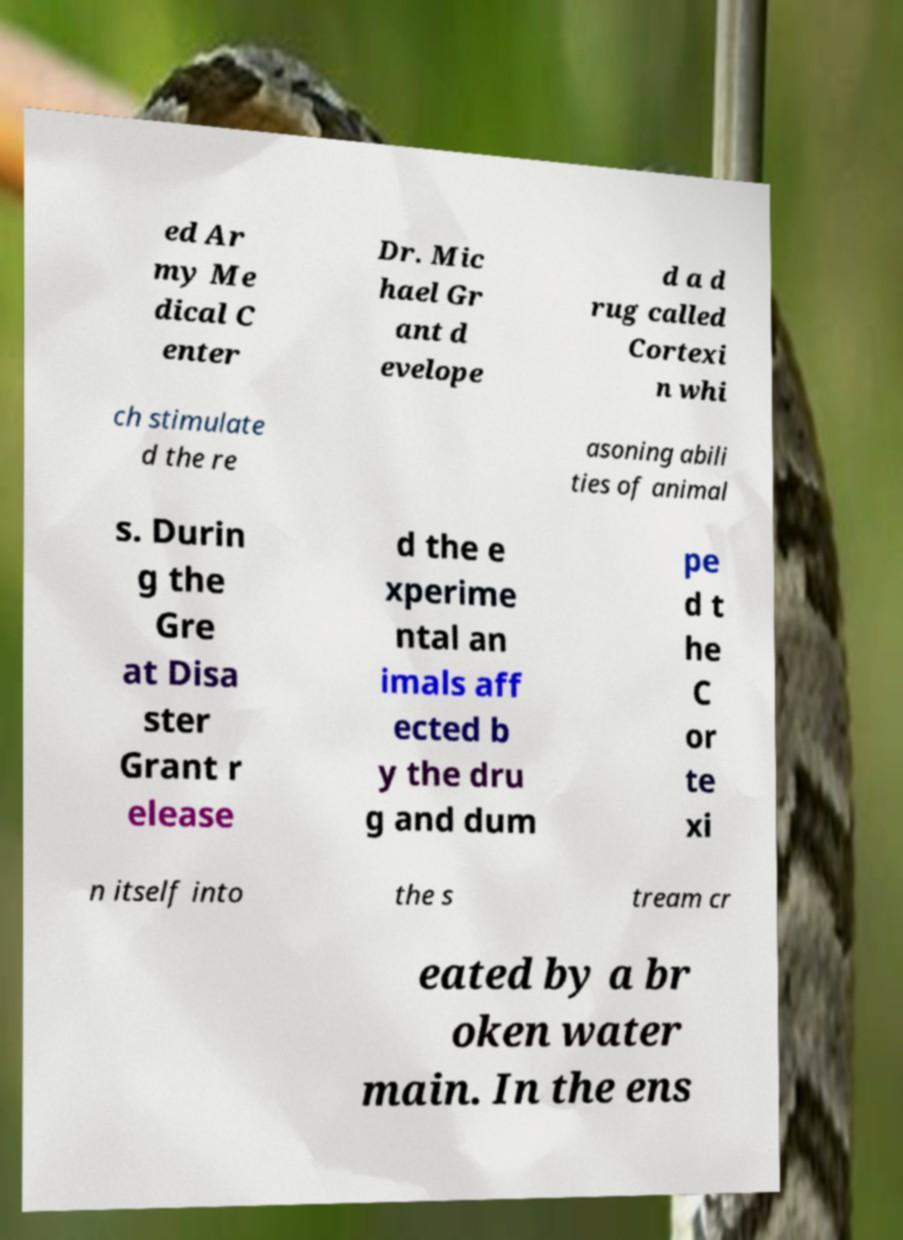Please identify and transcribe the text found in this image. ed Ar my Me dical C enter Dr. Mic hael Gr ant d evelope d a d rug called Cortexi n whi ch stimulate d the re asoning abili ties of animal s. Durin g the Gre at Disa ster Grant r elease d the e xperime ntal an imals aff ected b y the dru g and dum pe d t he C or te xi n itself into the s tream cr eated by a br oken water main. In the ens 